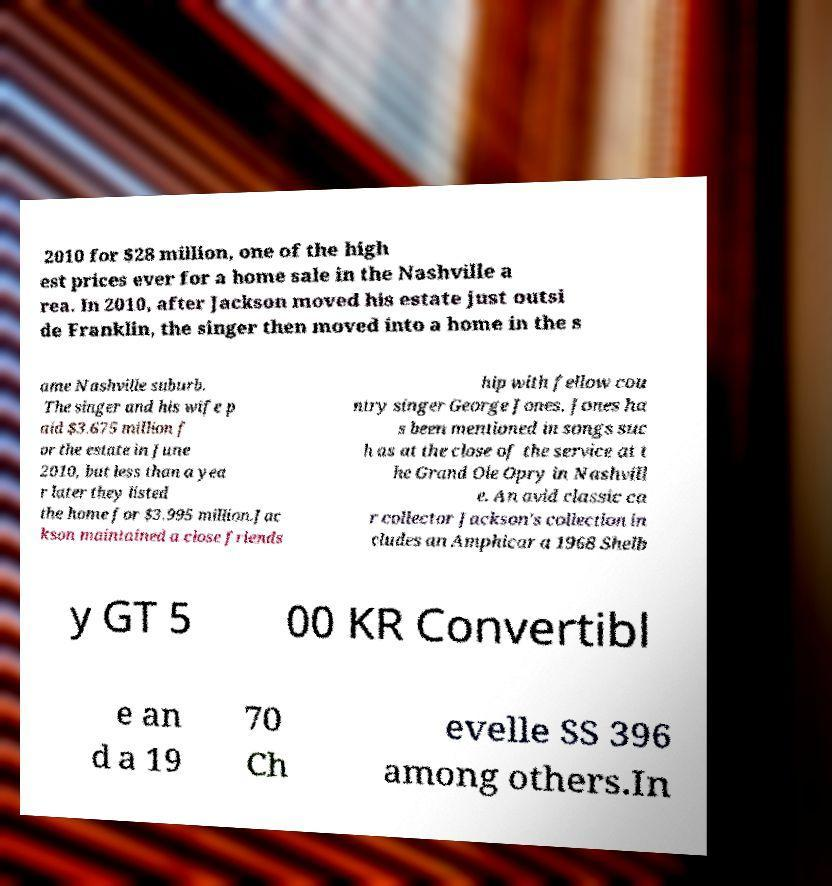I need the written content from this picture converted into text. Can you do that? 2010 for $28 million, one of the high est prices ever for a home sale in the Nashville a rea. In 2010, after Jackson moved his estate just outsi de Franklin, the singer then moved into a home in the s ame Nashville suburb. The singer and his wife p aid $3.675 million f or the estate in June 2010, but less than a yea r later they listed the home for $3.995 million.Jac kson maintained a close friends hip with fellow cou ntry singer George Jones. Jones ha s been mentioned in songs suc h as at the close of the service at t he Grand Ole Opry in Nashvill e. An avid classic ca r collector Jackson's collection in cludes an Amphicar a 1968 Shelb y GT 5 00 KR Convertibl e an d a 19 70 Ch evelle SS 396 among others.In 